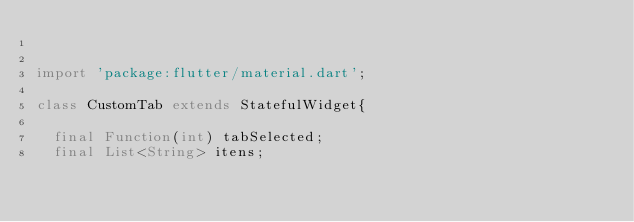Convert code to text. <code><loc_0><loc_0><loc_500><loc_500><_Dart_>

import 'package:flutter/material.dart';

class CustomTab extends StatefulWidget{

  final Function(int) tabSelected;
  final List<String> itens;
</code> 